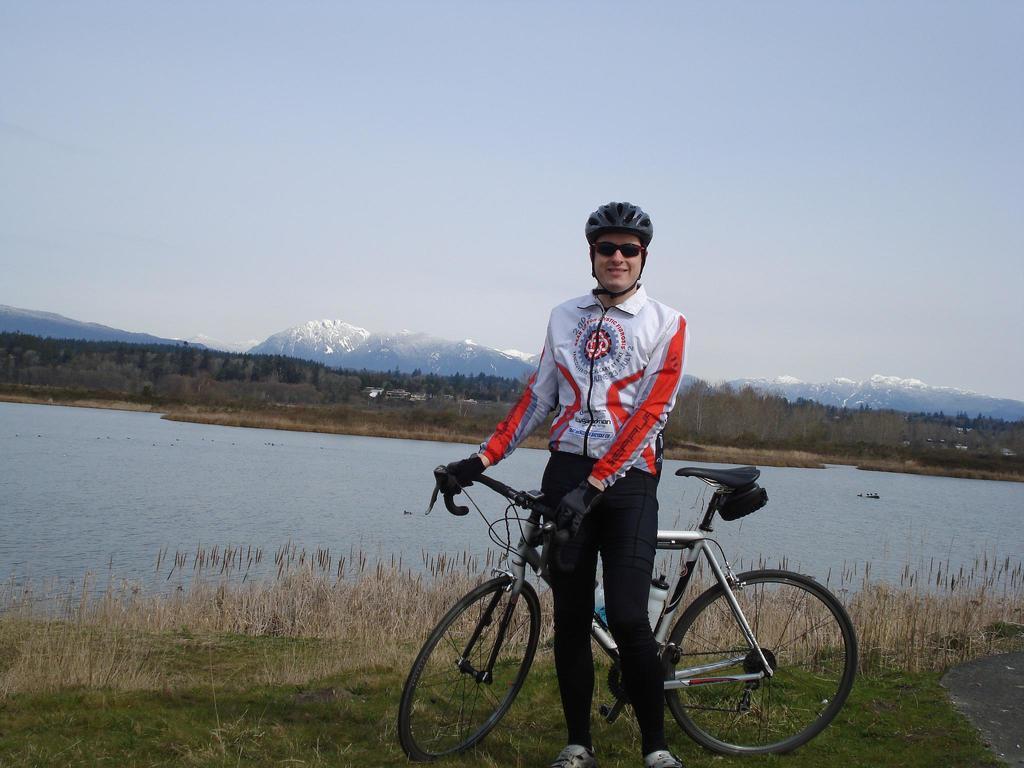In one or two sentences, can you explain what this image depicts? In this image we can see a person wearing sports jacket, wearing helmet, goggles, gloves holding bicycle in his hands and we can see a zipper attached to it and in the background of the image there is some water, there are some trees, mountains, clear sky. 